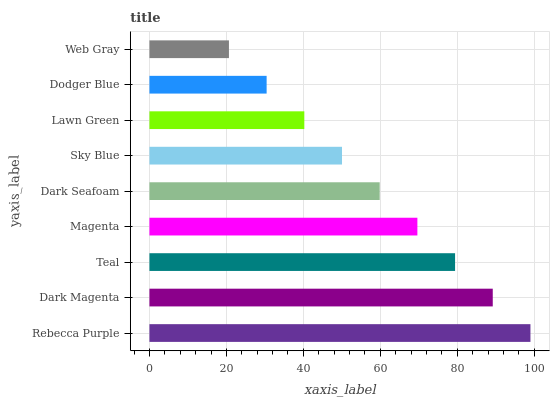Is Web Gray the minimum?
Answer yes or no. Yes. Is Rebecca Purple the maximum?
Answer yes or no. Yes. Is Dark Magenta the minimum?
Answer yes or no. No. Is Dark Magenta the maximum?
Answer yes or no. No. Is Rebecca Purple greater than Dark Magenta?
Answer yes or no. Yes. Is Dark Magenta less than Rebecca Purple?
Answer yes or no. Yes. Is Dark Magenta greater than Rebecca Purple?
Answer yes or no. No. Is Rebecca Purple less than Dark Magenta?
Answer yes or no. No. Is Dark Seafoam the high median?
Answer yes or no. Yes. Is Dark Seafoam the low median?
Answer yes or no. Yes. Is Dark Magenta the high median?
Answer yes or no. No. Is Magenta the low median?
Answer yes or no. No. 